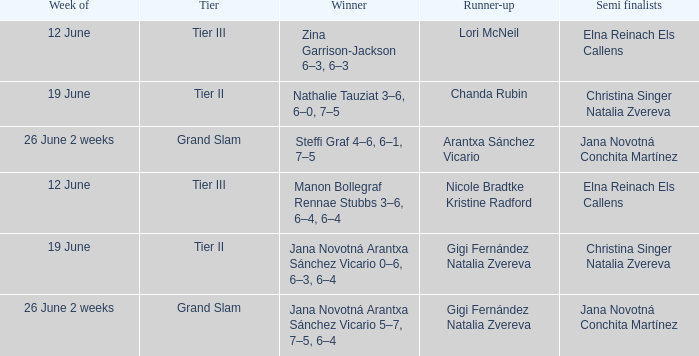In which week is the winner listed as Jana Novotná Arantxa Sánchez Vicario 5–7, 7–5, 6–4? 26 June 2 weeks. 